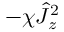Convert formula to latex. <formula><loc_0><loc_0><loc_500><loc_500>- \chi \hat { J } _ { z } ^ { 2 }</formula> 